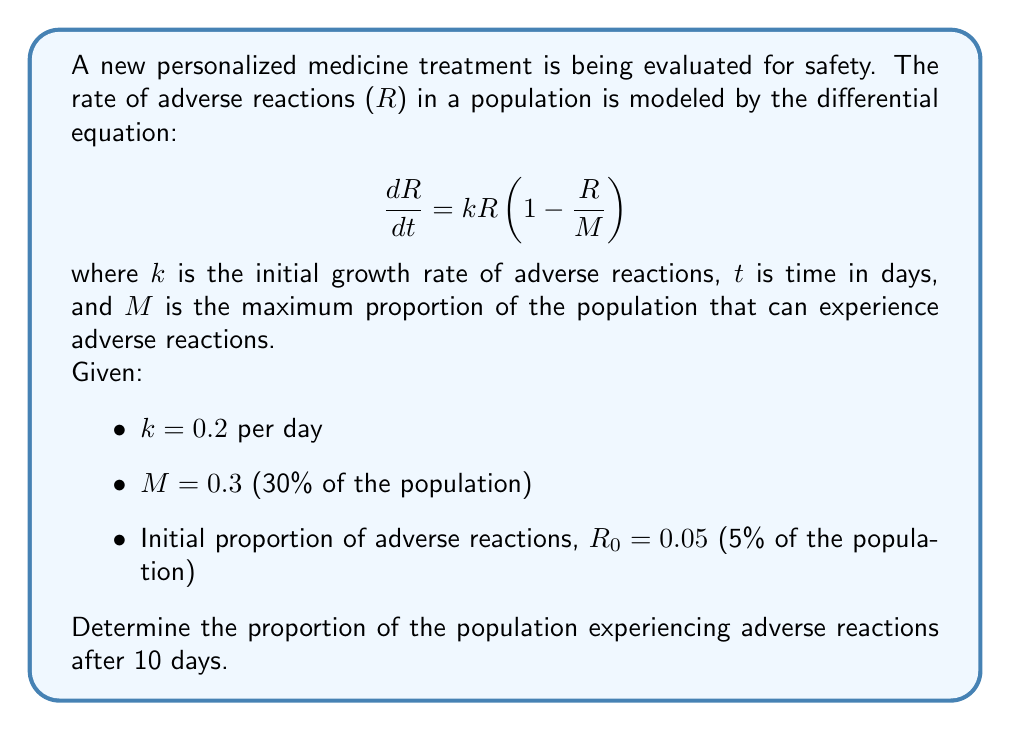Solve this math problem. To solve this problem, we need to use the logistic growth model, which is represented by the given differential equation. Let's solve it step by step:

1) The general solution for the logistic growth model is:

   $$R(t) = \frac{M}{1 + (\frac{M}{R_0} - 1)e^{-kt}}$$

2) We are given the following values:
   $k = 0.2$ per day
   $M = 0.3$
   $R_0 = 0.05$
   $t = 10$ days

3) Let's substitute these values into the equation:

   $$R(10) = \frac{0.3}{1 + (\frac{0.3}{0.05} - 1)e^{-0.2(10)}}$$

4) Simplify the fraction inside the parentheses:
   
   $$R(10) = \frac{0.3}{1 + (6 - 1)e^{-2}}$$

5) Calculate $e^{-2}$:
   
   $$R(10) = \frac{0.3}{1 + 5(0.1353)}$$

6) Multiply inside the parentheses:
   
   $$R(10) = \frac{0.3}{1 + 0.6765}$$

7) Add in the denominator:
   
   $$R(10) = \frac{0.3}{1.6765}$$

8) Divide:
   
   $$R(10) \approx 0.1789$$

Therefore, after 10 days, approximately 17.89% of the population will be experiencing adverse reactions.
Answer: 0.1789 or 17.89% 